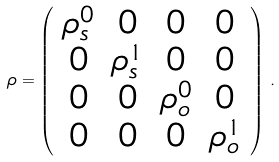Convert formula to latex. <formula><loc_0><loc_0><loc_500><loc_500>\rho = \left ( \begin{array} { c c c c } \rho ^ { 0 } _ { s } & 0 & 0 & 0 \\ 0 & \rho ^ { 1 } _ { s } & 0 & 0 \\ 0 & 0 & \rho ^ { 0 } _ { o } & 0 \\ 0 & 0 & 0 & \rho ^ { 1 } _ { o } \end{array} \right ) \, .</formula> 